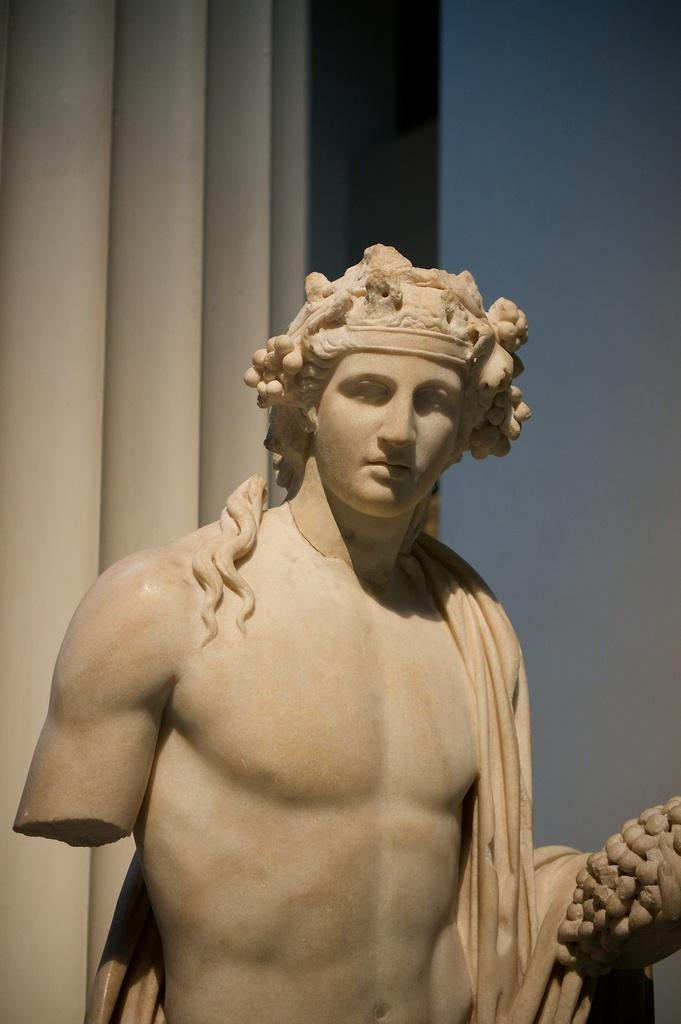What is the main subject of the image? There is a statue in the image. What type of secretary can be seen working in the clouds above the statue in the image? There are no clouds or secretaries present in the image; it only features a statue. 